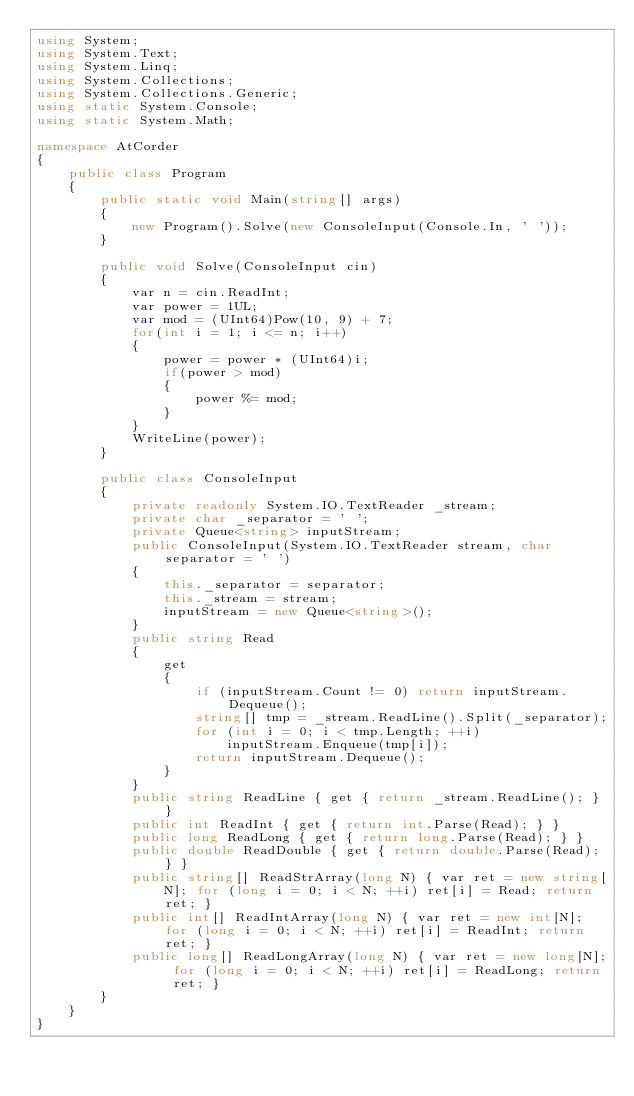Convert code to text. <code><loc_0><loc_0><loc_500><loc_500><_C#_>using System;
using System.Text;
using System.Linq;
using System.Collections;
using System.Collections.Generic;
using static System.Console;
using static System.Math;

namespace AtCorder
{
    public class Program
    {
        public static void Main(string[] args)
        {
            new Program().Solve(new ConsoleInput(Console.In, ' '));
        }

        public void Solve(ConsoleInput cin)
        {
            var n = cin.ReadInt;
            var power = 1UL;
            var mod = (UInt64)Pow(10, 9) + 7;
            for(int i = 1; i <= n; i++)
            {
                power = power * (UInt64)i;
                if(power > mod)
                {
                    power %= mod;
                }
            }
            WriteLine(power);
        }

        public class ConsoleInput
        {
            private readonly System.IO.TextReader _stream;
            private char _separator = ' ';
            private Queue<string> inputStream;
            public ConsoleInput(System.IO.TextReader stream, char separator = ' ')
            {
                this._separator = separator;
                this._stream = stream;
                inputStream = new Queue<string>();
            }
            public string Read
            {
                get
                {
                    if (inputStream.Count != 0) return inputStream.Dequeue();
                    string[] tmp = _stream.ReadLine().Split(_separator);
                    for (int i = 0; i < tmp.Length; ++i)
                        inputStream.Enqueue(tmp[i]);
                    return inputStream.Dequeue();
                }
            }
            public string ReadLine { get { return _stream.ReadLine(); } }
            public int ReadInt { get { return int.Parse(Read); } }
            public long ReadLong { get { return long.Parse(Read); } }
            public double ReadDouble { get { return double.Parse(Read); } }
            public string[] ReadStrArray(long N) { var ret = new string[N]; for (long i = 0; i < N; ++i) ret[i] = Read; return ret; }
            public int[] ReadIntArray(long N) { var ret = new int[N]; for (long i = 0; i < N; ++i) ret[i] = ReadInt; return ret; }
            public long[] ReadLongArray(long N) { var ret = new long[N]; for (long i = 0; i < N; ++i) ret[i] = ReadLong; return ret; }
        }
    }
}
</code> 